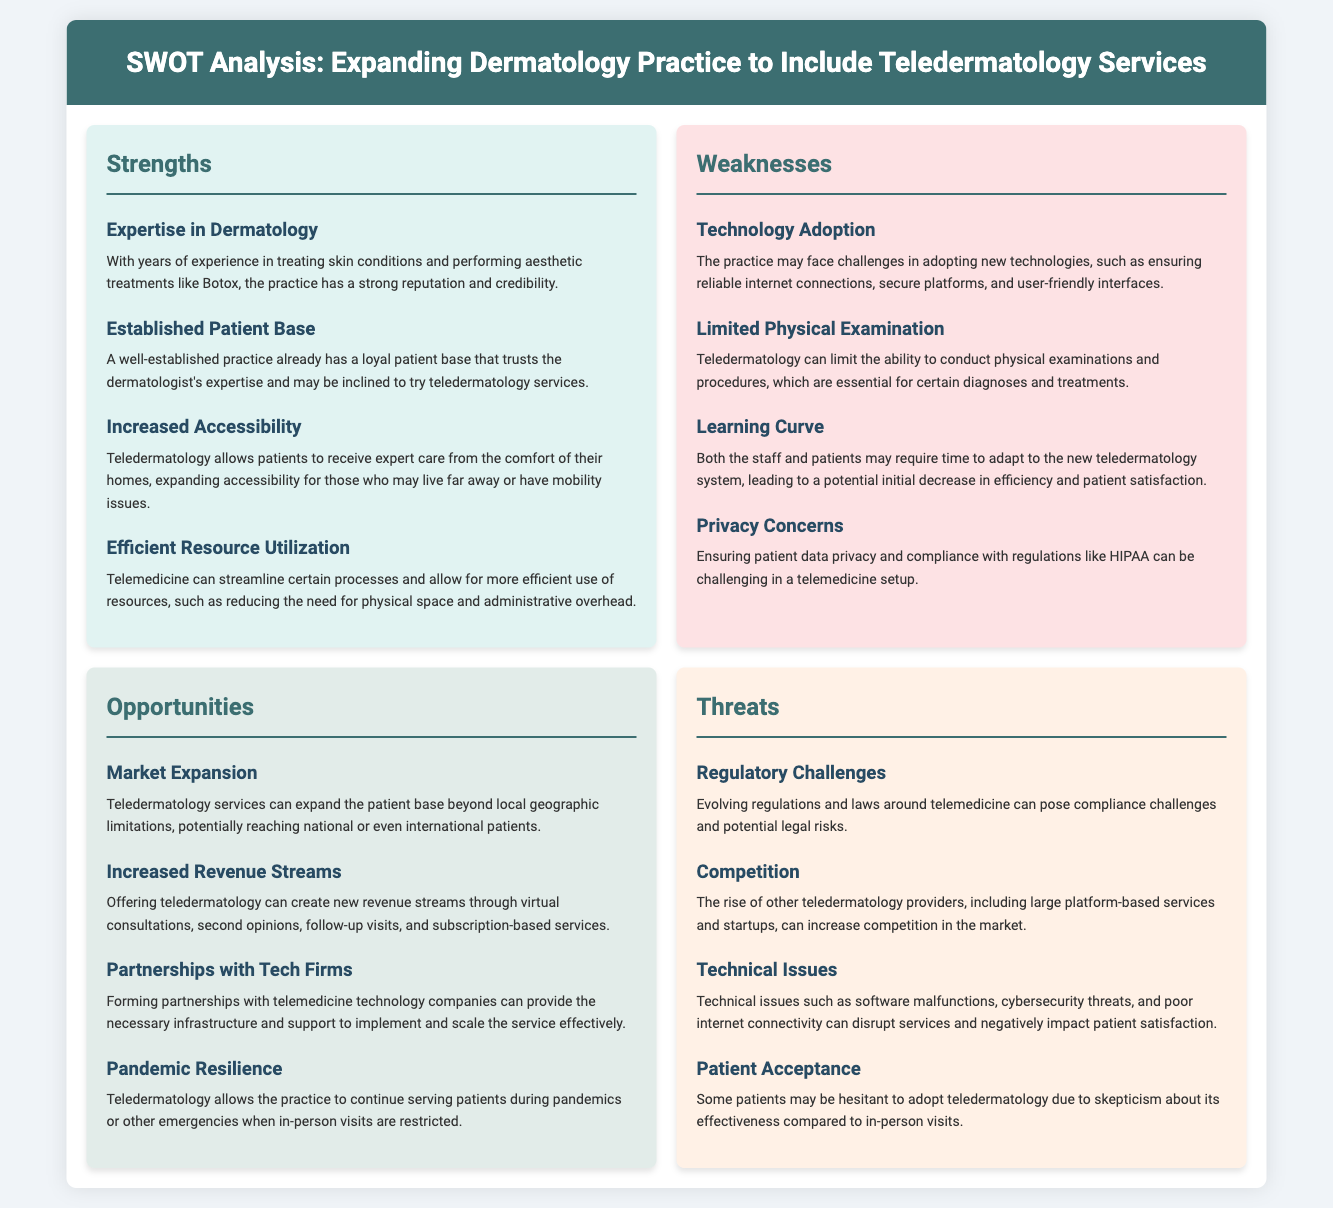what are the strengths listed in the SWOT analysis? The strengths are listed under the "Strengths" section in the SWOT analysis.
Answer: Expertise in Dermatology, Established Patient Base, Increased Accessibility, Efficient Resource Utilization what is the main opportunity for the dermatology practice? The main opportunity includes exploring new markets and expanding services to reach more patients.
Answer: Market Expansion how many weaknesses does the document identify? The document provides a total count of weaknesses listed in the "Weaknesses" section.
Answer: Four what regulatory risk is associated with teledermatology? The document mentions specific compliance challenges that may arise with teledermatology due to changing regulations.
Answer: Regulatory Challenges what is the concern regarding technology in the weaknesses section? This concern is related to the challenges faced when integrating new technologies into the practice.
Answer: Technology Adoption which threat involves potential issues with technology? This threat describes specific dangers associated with operational disruptions in teledermatology services.
Answer: Technical Issues how can teledermatology benefit patients during emergencies? The document highlights how teledermatology ensures continuity of care in crisis situations.
Answer: Pandemic Resilience what is one cited disadvantage of teledermatology regarding physical assessments? The analysis points out limitations in performing necessary physical exams through teledermatology.
Answer: Limited Physical Examination 